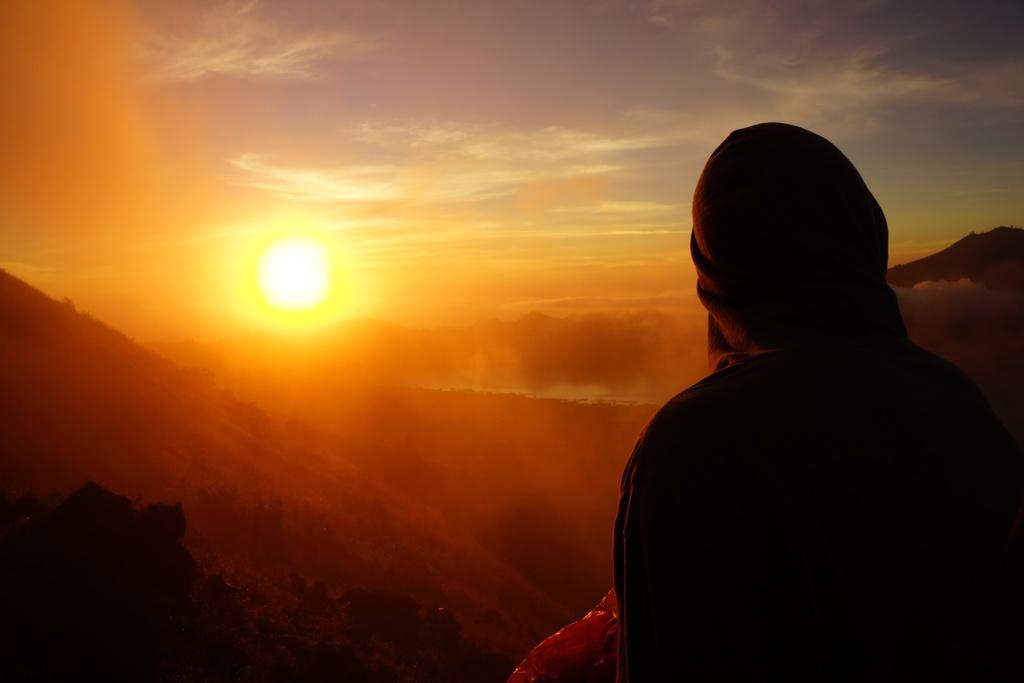Who is present in the image? There is a man in the image. Where is the man located in the image? The man is on the right side of the image. What type of natural environment can be seen in the image? There are trees in the image. What is the condition of the sky in the image? The sun is visible in the image. What type of coat is the man wearing in the image? There is no coat visible in the image; the man is not wearing one. Is the image set during the night or day? The image is set during the day, as the sun is visible. 